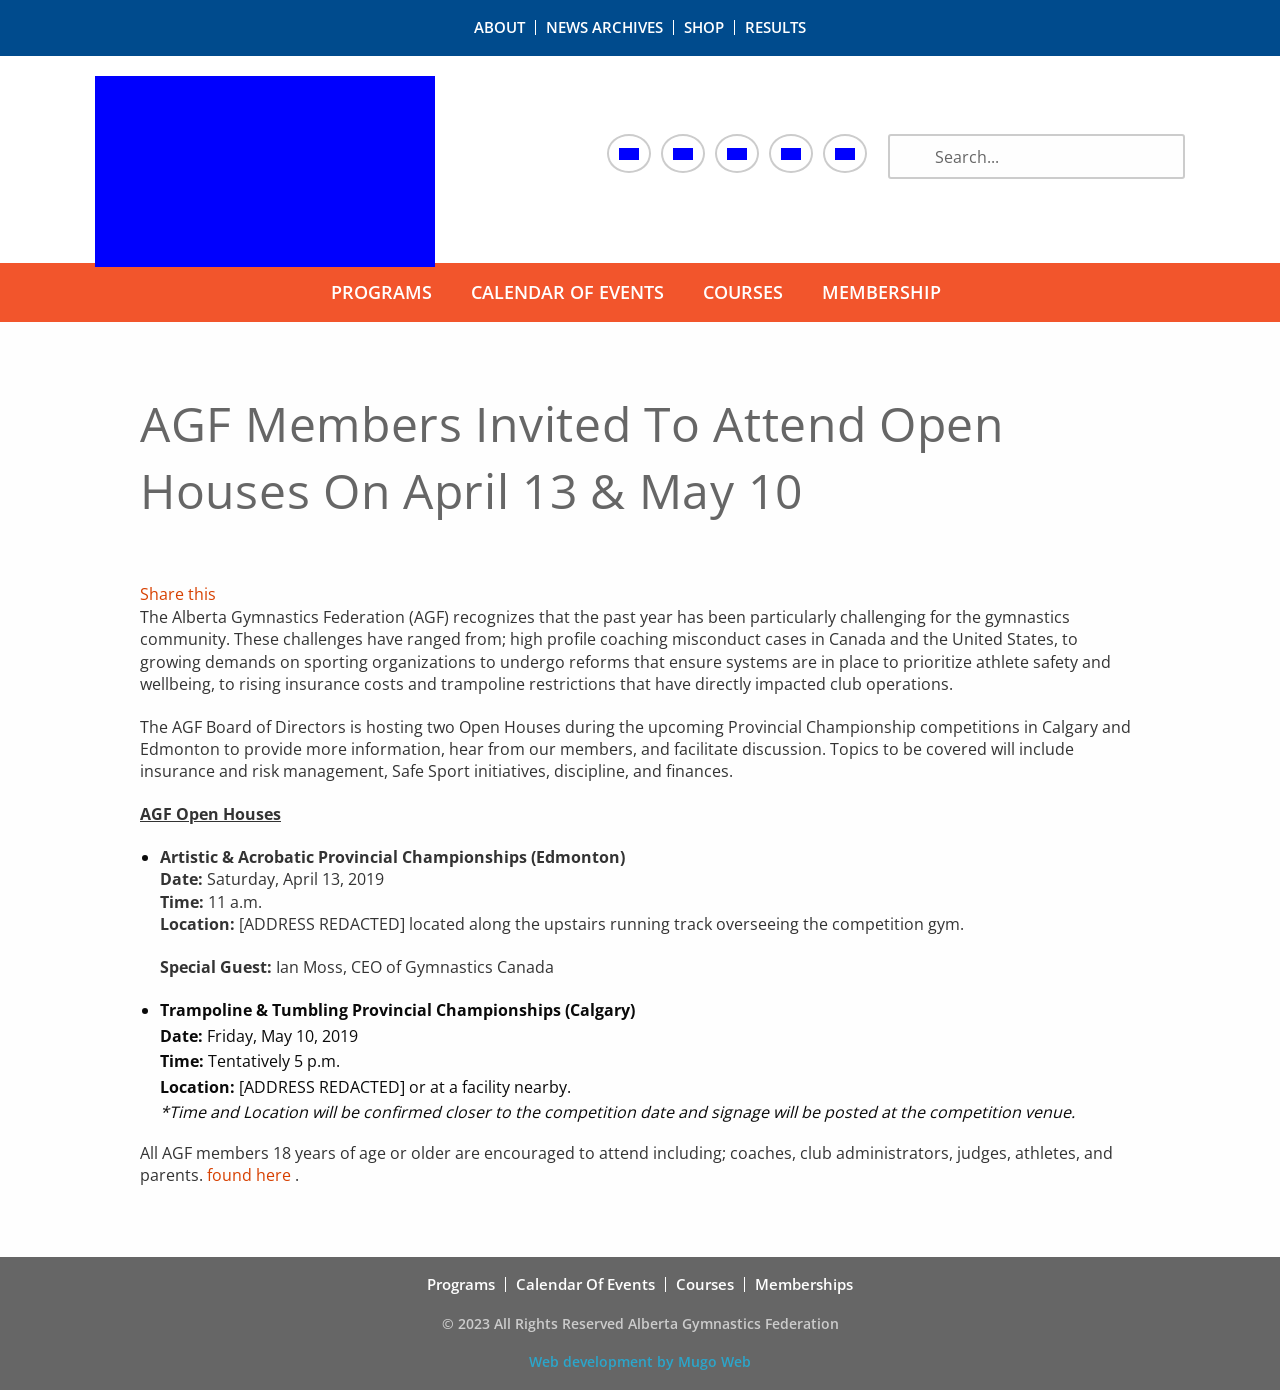What is the significance of having Ian Moss, CEO of Gymnastics Canada, as a special guest at one of the events? Having Ian Moss, CEO of Gymnastics Canada, as a special guest is significant because it shows a strong alignment and support from the national gymnastics body. His presence underscores the importance of the topics being discussed, particularly in light of recent challenges within the sport nationally and internationally. His insights and authority can help drive meaningful discussions and actions around the reforms needed to protect athletes and enhance the sport’s governance. 